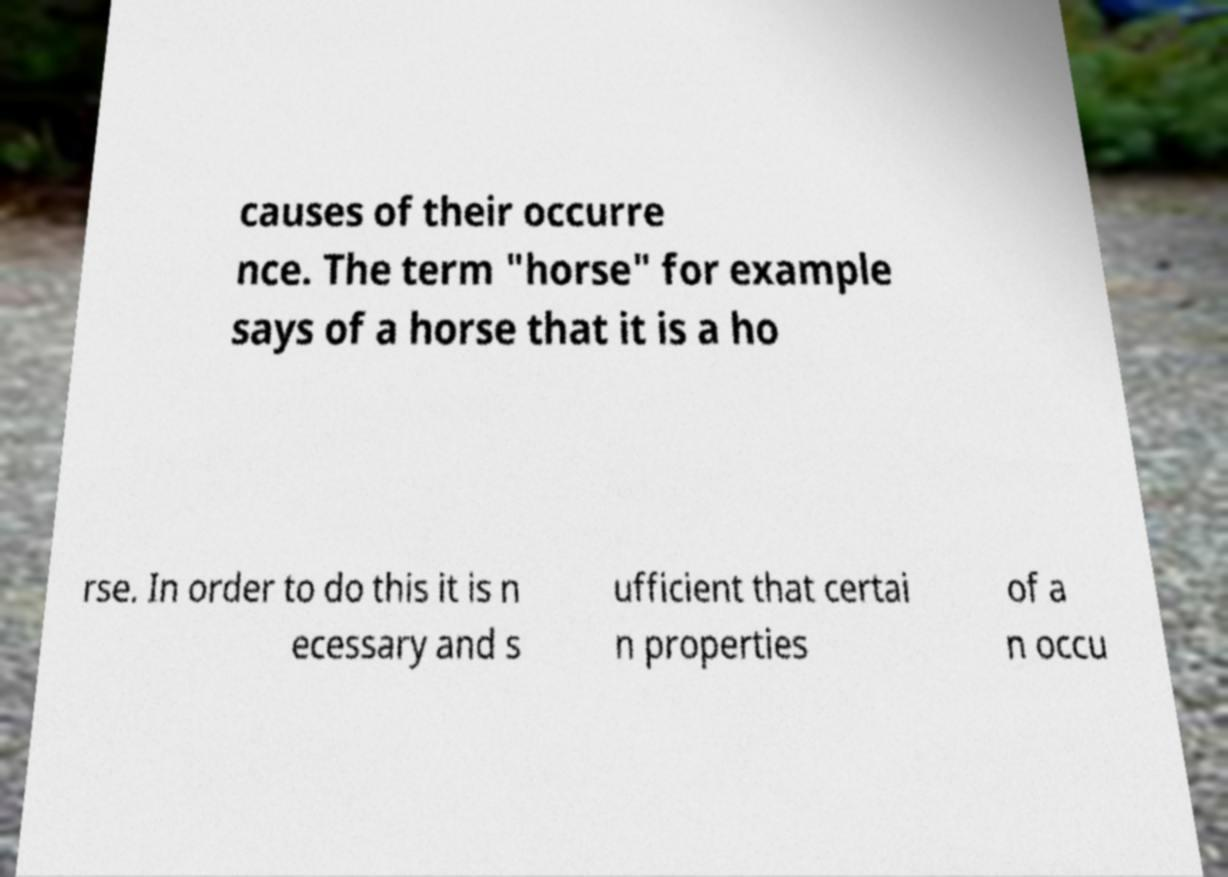Please identify and transcribe the text found in this image. causes of their occurre nce. The term "horse" for example says of a horse that it is a ho rse. In order to do this it is n ecessary and s ufficient that certai n properties of a n occu 